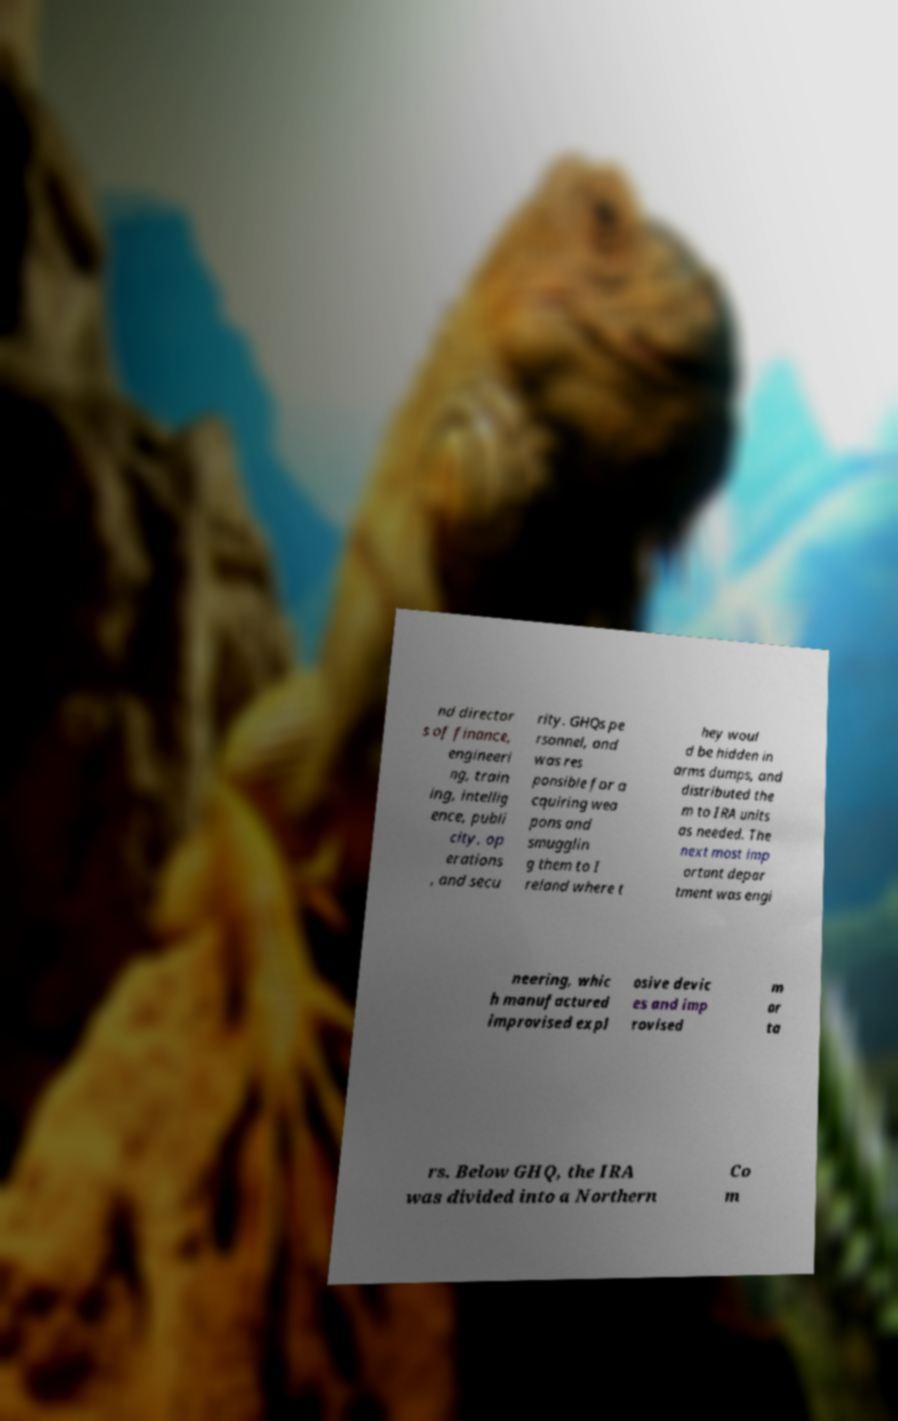There's text embedded in this image that I need extracted. Can you transcribe it verbatim? nd director s of finance, engineeri ng, train ing, intellig ence, publi city, op erations , and secu rity. GHQs pe rsonnel, and was res ponsible for a cquiring wea pons and smugglin g them to I reland where t hey woul d be hidden in arms dumps, and distributed the m to IRA units as needed. The next most imp ortant depar tment was engi neering, whic h manufactured improvised expl osive devic es and imp rovised m or ta rs. Below GHQ, the IRA was divided into a Northern Co m 